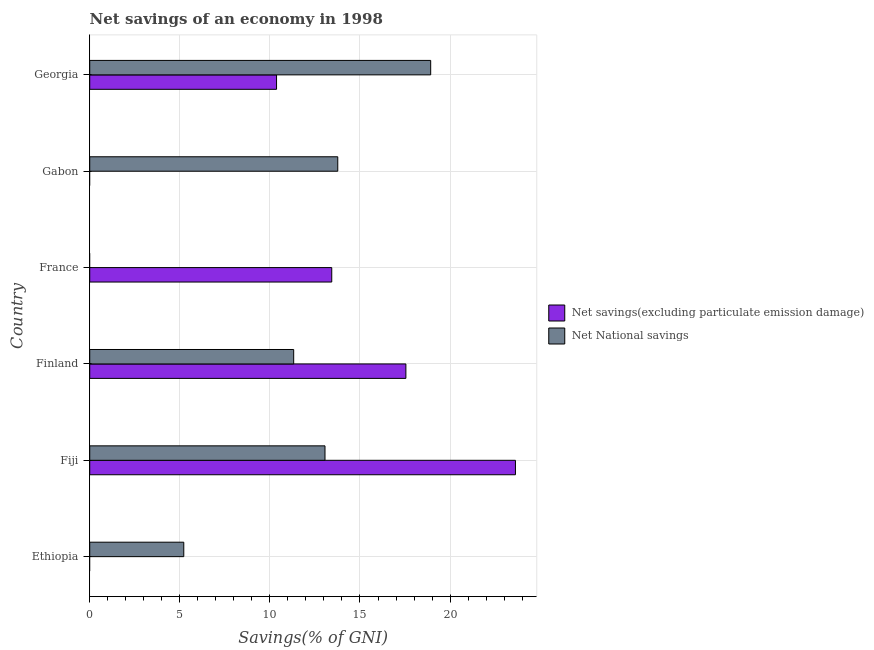Are the number of bars on each tick of the Y-axis equal?
Make the answer very short. No. How many bars are there on the 2nd tick from the top?
Ensure brevity in your answer.  1. How many bars are there on the 2nd tick from the bottom?
Provide a succinct answer. 2. What is the label of the 1st group of bars from the top?
Ensure brevity in your answer.  Georgia. In how many cases, is the number of bars for a given country not equal to the number of legend labels?
Offer a terse response. 3. What is the net savings(excluding particulate emission damage) in Gabon?
Your answer should be compact. 0. Across all countries, what is the maximum net national savings?
Your response must be concise. 18.92. In which country was the net savings(excluding particulate emission damage) maximum?
Offer a very short reply. Fiji. What is the total net national savings in the graph?
Provide a succinct answer. 62.29. What is the difference between the net national savings in Fiji and that in Finland?
Offer a terse response. 1.74. What is the difference between the net national savings in Ethiopia and the net savings(excluding particulate emission damage) in Gabon?
Your response must be concise. 5.22. What is the average net national savings per country?
Keep it short and to the point. 10.38. What is the difference between the net savings(excluding particulate emission damage) and net national savings in Finland?
Your answer should be very brief. 6.23. In how many countries, is the net savings(excluding particulate emission damage) greater than 3 %?
Ensure brevity in your answer.  4. What is the ratio of the net national savings in Finland to that in Gabon?
Provide a short and direct response. 0.82. Is the net national savings in Ethiopia less than that in Finland?
Provide a succinct answer. Yes. Is the difference between the net national savings in Finland and Georgia greater than the difference between the net savings(excluding particulate emission damage) in Finland and Georgia?
Provide a succinct answer. No. What is the difference between the highest and the second highest net savings(excluding particulate emission damage)?
Give a very brief answer. 6.08. What is the difference between the highest and the lowest net national savings?
Your response must be concise. 18.92. How many countries are there in the graph?
Your answer should be very brief. 6. What is the difference between two consecutive major ticks on the X-axis?
Your answer should be very brief. 5. Are the values on the major ticks of X-axis written in scientific E-notation?
Keep it short and to the point. No. Does the graph contain any zero values?
Your answer should be compact. Yes. Where does the legend appear in the graph?
Ensure brevity in your answer.  Center right. How are the legend labels stacked?
Your answer should be compact. Vertical. What is the title of the graph?
Offer a very short reply. Net savings of an economy in 1998. Does "Nonresident" appear as one of the legend labels in the graph?
Give a very brief answer. No. What is the label or title of the X-axis?
Offer a terse response. Savings(% of GNI). What is the Savings(% of GNI) in Net National savings in Ethiopia?
Keep it short and to the point. 5.22. What is the Savings(% of GNI) of Net savings(excluding particulate emission damage) in Fiji?
Provide a short and direct response. 23.63. What is the Savings(% of GNI) in Net National savings in Fiji?
Make the answer very short. 13.06. What is the Savings(% of GNI) in Net savings(excluding particulate emission damage) in Finland?
Give a very brief answer. 17.55. What is the Savings(% of GNI) in Net National savings in Finland?
Provide a short and direct response. 11.32. What is the Savings(% of GNI) of Net savings(excluding particulate emission damage) in France?
Provide a short and direct response. 13.43. What is the Savings(% of GNI) in Net National savings in France?
Keep it short and to the point. 0. What is the Savings(% of GNI) of Net National savings in Gabon?
Provide a short and direct response. 13.77. What is the Savings(% of GNI) in Net savings(excluding particulate emission damage) in Georgia?
Offer a terse response. 10.37. What is the Savings(% of GNI) of Net National savings in Georgia?
Your answer should be very brief. 18.92. Across all countries, what is the maximum Savings(% of GNI) in Net savings(excluding particulate emission damage)?
Keep it short and to the point. 23.63. Across all countries, what is the maximum Savings(% of GNI) in Net National savings?
Provide a succinct answer. 18.92. Across all countries, what is the minimum Savings(% of GNI) of Net National savings?
Keep it short and to the point. 0. What is the total Savings(% of GNI) in Net savings(excluding particulate emission damage) in the graph?
Provide a short and direct response. 64.98. What is the total Savings(% of GNI) of Net National savings in the graph?
Ensure brevity in your answer.  62.29. What is the difference between the Savings(% of GNI) in Net National savings in Ethiopia and that in Fiji?
Keep it short and to the point. -7.84. What is the difference between the Savings(% of GNI) in Net National savings in Ethiopia and that in Finland?
Ensure brevity in your answer.  -6.1. What is the difference between the Savings(% of GNI) in Net National savings in Ethiopia and that in Gabon?
Give a very brief answer. -8.55. What is the difference between the Savings(% of GNI) of Net National savings in Ethiopia and that in Georgia?
Provide a short and direct response. -13.7. What is the difference between the Savings(% of GNI) of Net savings(excluding particulate emission damage) in Fiji and that in Finland?
Your answer should be compact. 6.08. What is the difference between the Savings(% of GNI) in Net National savings in Fiji and that in Finland?
Your response must be concise. 1.74. What is the difference between the Savings(% of GNI) in Net savings(excluding particulate emission damage) in Fiji and that in France?
Ensure brevity in your answer.  10.2. What is the difference between the Savings(% of GNI) in Net National savings in Fiji and that in Gabon?
Your answer should be very brief. -0.71. What is the difference between the Savings(% of GNI) of Net savings(excluding particulate emission damage) in Fiji and that in Georgia?
Keep it short and to the point. 13.26. What is the difference between the Savings(% of GNI) of Net National savings in Fiji and that in Georgia?
Offer a very short reply. -5.87. What is the difference between the Savings(% of GNI) of Net savings(excluding particulate emission damage) in Finland and that in France?
Your response must be concise. 4.12. What is the difference between the Savings(% of GNI) of Net National savings in Finland and that in Gabon?
Ensure brevity in your answer.  -2.45. What is the difference between the Savings(% of GNI) in Net savings(excluding particulate emission damage) in Finland and that in Georgia?
Keep it short and to the point. 7.18. What is the difference between the Savings(% of GNI) of Net National savings in Finland and that in Georgia?
Make the answer very short. -7.6. What is the difference between the Savings(% of GNI) in Net savings(excluding particulate emission damage) in France and that in Georgia?
Your response must be concise. 3.06. What is the difference between the Savings(% of GNI) of Net National savings in Gabon and that in Georgia?
Ensure brevity in your answer.  -5.16. What is the difference between the Savings(% of GNI) of Net savings(excluding particulate emission damage) in Fiji and the Savings(% of GNI) of Net National savings in Finland?
Your response must be concise. 12.31. What is the difference between the Savings(% of GNI) of Net savings(excluding particulate emission damage) in Fiji and the Savings(% of GNI) of Net National savings in Gabon?
Provide a succinct answer. 9.86. What is the difference between the Savings(% of GNI) of Net savings(excluding particulate emission damage) in Fiji and the Savings(% of GNI) of Net National savings in Georgia?
Provide a short and direct response. 4.7. What is the difference between the Savings(% of GNI) in Net savings(excluding particulate emission damage) in Finland and the Savings(% of GNI) in Net National savings in Gabon?
Provide a short and direct response. 3.78. What is the difference between the Savings(% of GNI) in Net savings(excluding particulate emission damage) in Finland and the Savings(% of GNI) in Net National savings in Georgia?
Keep it short and to the point. -1.38. What is the difference between the Savings(% of GNI) in Net savings(excluding particulate emission damage) in France and the Savings(% of GNI) in Net National savings in Gabon?
Offer a terse response. -0.33. What is the difference between the Savings(% of GNI) of Net savings(excluding particulate emission damage) in France and the Savings(% of GNI) of Net National savings in Georgia?
Offer a terse response. -5.49. What is the average Savings(% of GNI) of Net savings(excluding particulate emission damage) per country?
Give a very brief answer. 10.83. What is the average Savings(% of GNI) in Net National savings per country?
Ensure brevity in your answer.  10.38. What is the difference between the Savings(% of GNI) of Net savings(excluding particulate emission damage) and Savings(% of GNI) of Net National savings in Fiji?
Provide a short and direct response. 10.57. What is the difference between the Savings(% of GNI) of Net savings(excluding particulate emission damage) and Savings(% of GNI) of Net National savings in Finland?
Offer a very short reply. 6.23. What is the difference between the Savings(% of GNI) in Net savings(excluding particulate emission damage) and Savings(% of GNI) in Net National savings in Georgia?
Ensure brevity in your answer.  -8.56. What is the ratio of the Savings(% of GNI) of Net National savings in Ethiopia to that in Fiji?
Your answer should be very brief. 0.4. What is the ratio of the Savings(% of GNI) of Net National savings in Ethiopia to that in Finland?
Give a very brief answer. 0.46. What is the ratio of the Savings(% of GNI) in Net National savings in Ethiopia to that in Gabon?
Provide a short and direct response. 0.38. What is the ratio of the Savings(% of GNI) in Net National savings in Ethiopia to that in Georgia?
Offer a very short reply. 0.28. What is the ratio of the Savings(% of GNI) in Net savings(excluding particulate emission damage) in Fiji to that in Finland?
Give a very brief answer. 1.35. What is the ratio of the Savings(% of GNI) in Net National savings in Fiji to that in Finland?
Your answer should be compact. 1.15. What is the ratio of the Savings(% of GNI) of Net savings(excluding particulate emission damage) in Fiji to that in France?
Offer a terse response. 1.76. What is the ratio of the Savings(% of GNI) in Net National savings in Fiji to that in Gabon?
Your response must be concise. 0.95. What is the ratio of the Savings(% of GNI) of Net savings(excluding particulate emission damage) in Fiji to that in Georgia?
Provide a succinct answer. 2.28. What is the ratio of the Savings(% of GNI) of Net National savings in Fiji to that in Georgia?
Your answer should be very brief. 0.69. What is the ratio of the Savings(% of GNI) of Net savings(excluding particulate emission damage) in Finland to that in France?
Your answer should be very brief. 1.31. What is the ratio of the Savings(% of GNI) of Net National savings in Finland to that in Gabon?
Your answer should be compact. 0.82. What is the ratio of the Savings(% of GNI) in Net savings(excluding particulate emission damage) in Finland to that in Georgia?
Give a very brief answer. 1.69. What is the ratio of the Savings(% of GNI) of Net National savings in Finland to that in Georgia?
Offer a terse response. 0.6. What is the ratio of the Savings(% of GNI) in Net savings(excluding particulate emission damage) in France to that in Georgia?
Offer a very short reply. 1.3. What is the ratio of the Savings(% of GNI) of Net National savings in Gabon to that in Georgia?
Provide a short and direct response. 0.73. What is the difference between the highest and the second highest Savings(% of GNI) of Net savings(excluding particulate emission damage)?
Keep it short and to the point. 6.08. What is the difference between the highest and the second highest Savings(% of GNI) of Net National savings?
Offer a very short reply. 5.16. What is the difference between the highest and the lowest Savings(% of GNI) of Net savings(excluding particulate emission damage)?
Keep it short and to the point. 23.63. What is the difference between the highest and the lowest Savings(% of GNI) in Net National savings?
Keep it short and to the point. 18.92. 